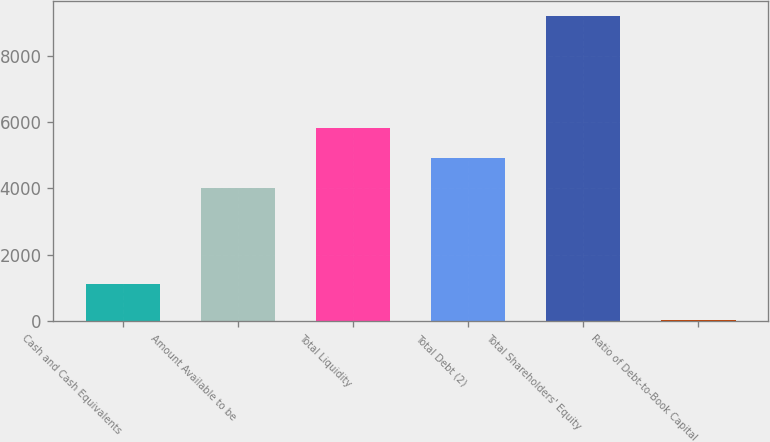<chart> <loc_0><loc_0><loc_500><loc_500><bar_chart><fcel>Cash and Cash Equivalents<fcel>Amount Available to be<fcel>Total Liquidity<fcel>Total Debt (2)<fcel>Total Shareholders' Equity<fcel>Ratio of Debt-to-Book Capital<nl><fcel>1117<fcel>4000<fcel>5829.8<fcel>4914.9<fcel>9184<fcel>35<nl></chart> 